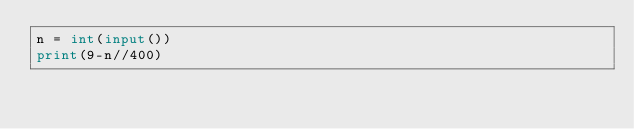<code> <loc_0><loc_0><loc_500><loc_500><_Python_>n = int(input())
print(9-n//400)</code> 